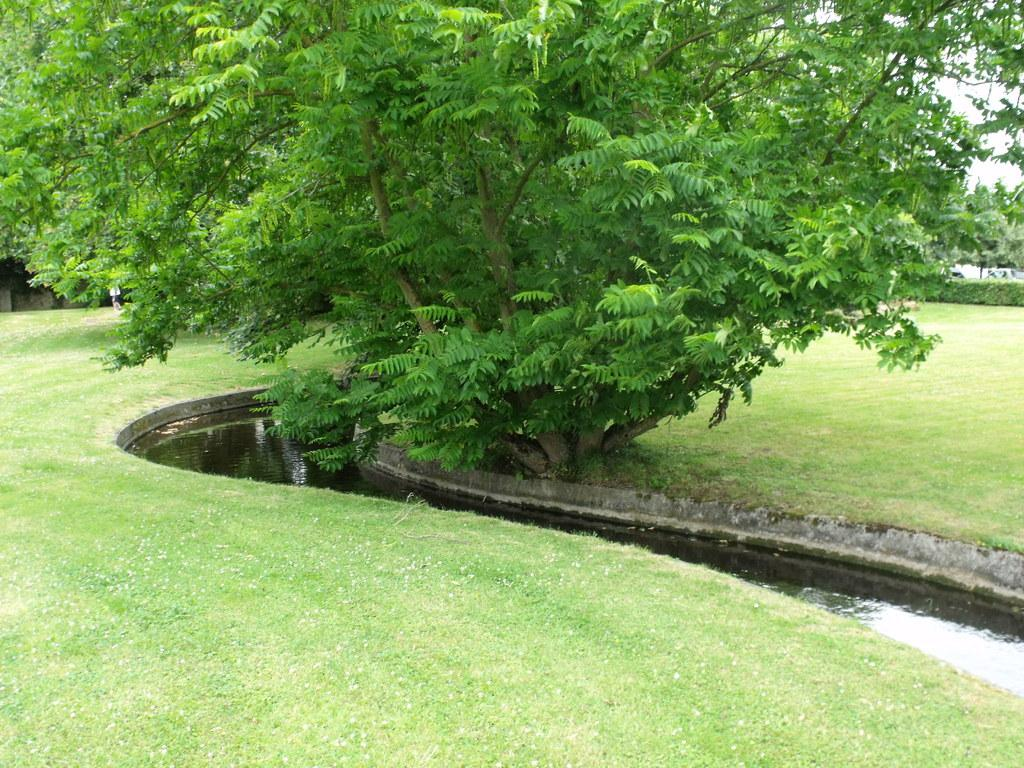What type of vegetation can be seen in the image? There are green color trees in the image. What natural element is visible besides the trees? There is water visible in the image. What is the color of the sky in the image? The sky appears to be white in color. How many wheels can be seen on the trees in the image? There are no wheels present on the trees in the image, as trees do not have wheels. 